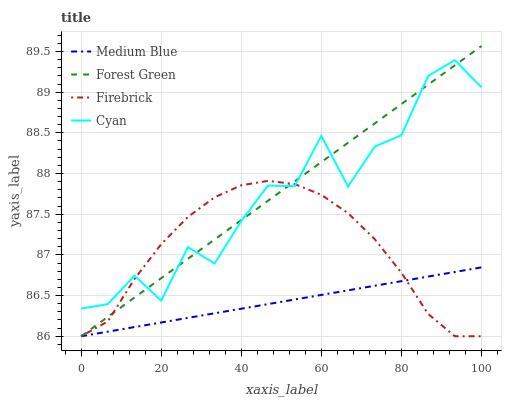Does Medium Blue have the minimum area under the curve?
Answer yes or no. Yes. Does Forest Green have the maximum area under the curve?
Answer yes or no. Yes. Does Forest Green have the minimum area under the curve?
Answer yes or no. No. Does Medium Blue have the maximum area under the curve?
Answer yes or no. No. Is Medium Blue the smoothest?
Answer yes or no. Yes. Is Cyan the roughest?
Answer yes or no. Yes. Is Forest Green the smoothest?
Answer yes or no. No. Is Forest Green the roughest?
Answer yes or no. No. Does Forest Green have the highest value?
Answer yes or no. Yes. Does Medium Blue have the highest value?
Answer yes or no. No. Is Medium Blue less than Cyan?
Answer yes or no. Yes. Is Cyan greater than Medium Blue?
Answer yes or no. Yes. Does Cyan intersect Firebrick?
Answer yes or no. Yes. Is Cyan less than Firebrick?
Answer yes or no. No. Is Cyan greater than Firebrick?
Answer yes or no. No. Does Medium Blue intersect Cyan?
Answer yes or no. No. 